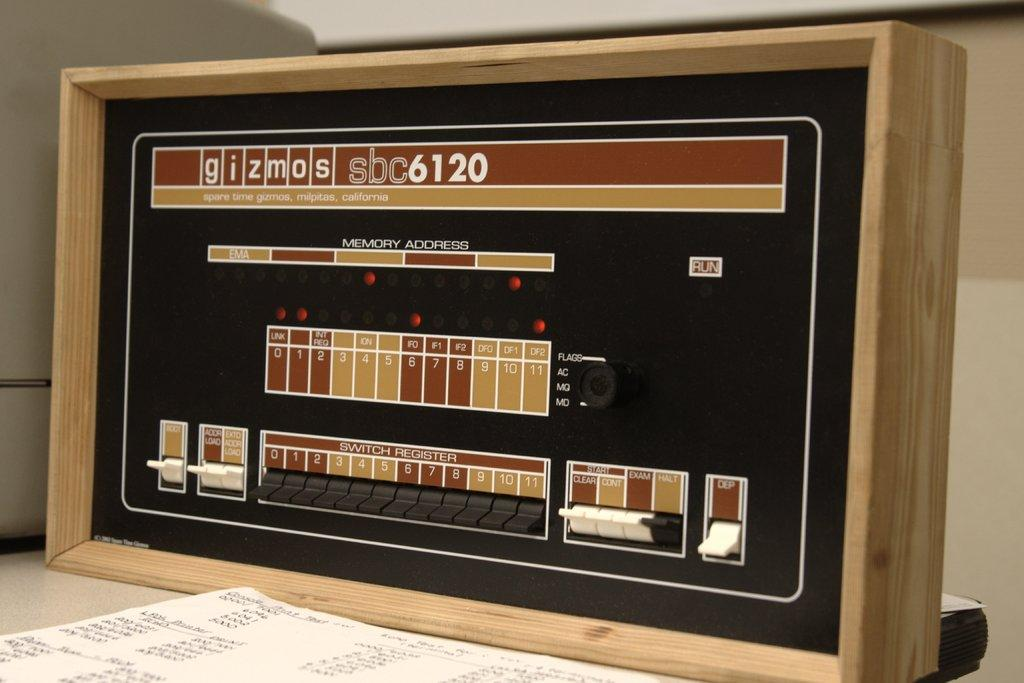<image>
Describe the image concisely. A gizmos 6120 is seen in various shades of brown. 